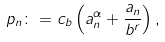<formula> <loc_0><loc_0><loc_500><loc_500>p _ { n } \colon = c _ { b } \left ( a _ { n } ^ { \alpha } + \frac { a _ { n } } { b ^ { r } } \right ) ,</formula> 